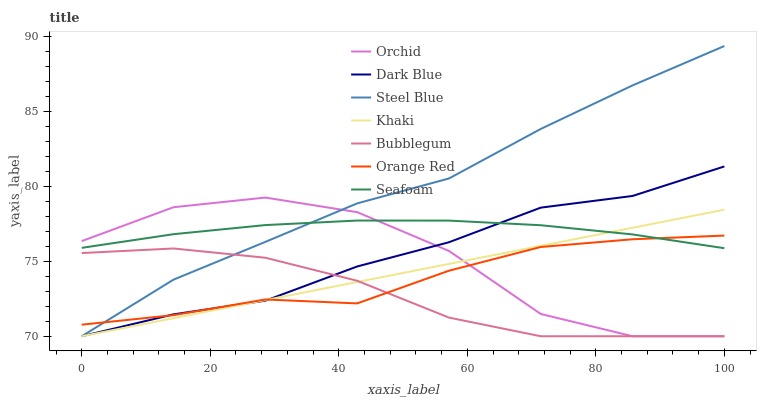Does Steel Blue have the minimum area under the curve?
Answer yes or no. No. Does Bubblegum have the maximum area under the curve?
Answer yes or no. No. Is Steel Blue the smoothest?
Answer yes or no. No. Is Steel Blue the roughest?
Answer yes or no. No. Does Seafoam have the lowest value?
Answer yes or no. No. Does Bubblegum have the highest value?
Answer yes or no. No. Is Bubblegum less than Seafoam?
Answer yes or no. Yes. Is Seafoam greater than Bubblegum?
Answer yes or no. Yes. Does Bubblegum intersect Seafoam?
Answer yes or no. No. 